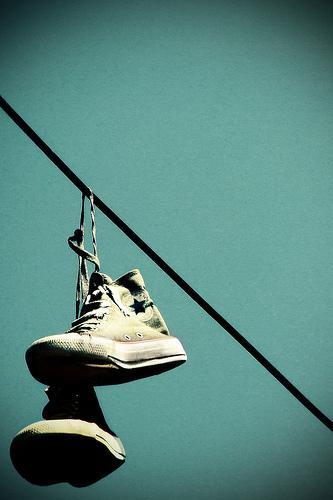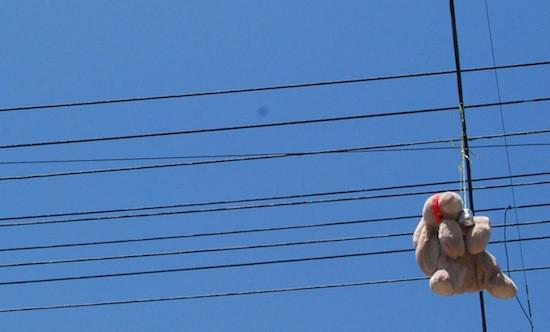The first image is the image on the left, the second image is the image on the right. Assess this claim about the two images: "There are more than 3 pairs of shoes hanging from an electric wire.". Correct or not? Answer yes or no. No. The first image is the image on the left, the second image is the image on the right. For the images shown, is this caption "One of the images shows multiple pairs of shoes hanging from a power line." true? Answer yes or no. No. 